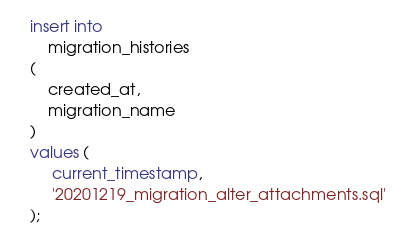Convert code to text. <code><loc_0><loc_0><loc_500><loc_500><_SQL_>insert into
    migration_histories
(
    created_at,
    migration_name
)
values (
     current_timestamp,
     '20201219_migration_alter_attachments.sql'
);
</code> 